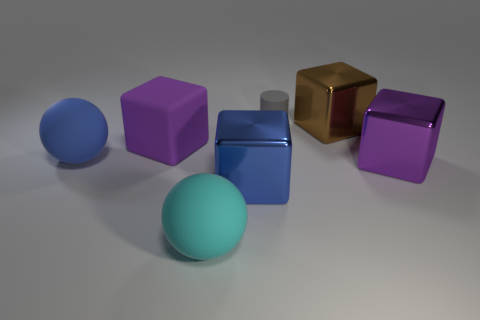Are there any other things that have the same size as the gray object?
Provide a succinct answer. No. How many large blue things have the same material as the small gray cylinder?
Make the answer very short. 1. Is the purple cube to the left of the brown metal thing made of the same material as the large cyan ball that is in front of the large blue metal block?
Ensure brevity in your answer.  Yes. There is a blue object that is on the right side of the matte sphere that is behind the big blue block; how many big blue balls are in front of it?
Offer a terse response. 0. There is a metal block that is to the left of the small thing; is it the same color as the large ball that is behind the big cyan sphere?
Keep it short and to the point. Yes. Is there anything else that has the same color as the small rubber thing?
Keep it short and to the point. No. The large matte ball to the left of the matte ball in front of the blue shiny block is what color?
Your answer should be compact. Blue. Are any large yellow metallic spheres visible?
Keep it short and to the point. No. The rubber object that is both on the right side of the big purple rubber cube and in front of the tiny rubber thing is what color?
Offer a very short reply. Cyan. There is a block that is left of the blue metallic cube; does it have the same size as the purple block on the right side of the cylinder?
Make the answer very short. Yes. 